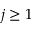<formula> <loc_0><loc_0><loc_500><loc_500>j \geq 1</formula> 